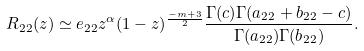<formula> <loc_0><loc_0><loc_500><loc_500>R _ { 2 2 } ( z ) & \simeq e _ { 2 2 } z ^ { \alpha } ( 1 - z ) ^ { \frac { - m + 3 } { 2 } } \frac { \Gamma ( c ) \Gamma ( a _ { 2 2 } + b _ { 2 2 } - c ) } { \Gamma ( a _ { 2 2 } ) \Gamma ( b _ { 2 2 } ) } .</formula> 